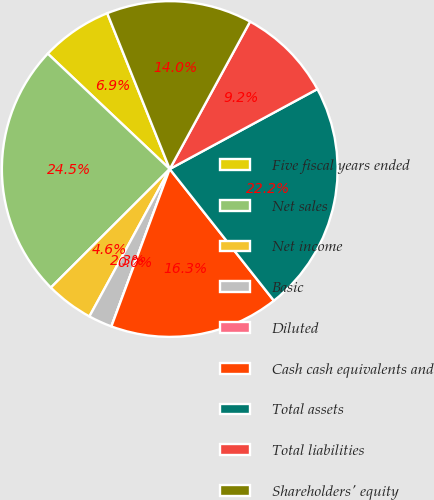<chart> <loc_0><loc_0><loc_500><loc_500><pie_chart><fcel>Five fiscal years ended<fcel>Net sales<fcel>Net income<fcel>Basic<fcel>Diluted<fcel>Cash cash equivalents and<fcel>Total assets<fcel>Total liabilities<fcel>Shareholders' equity<nl><fcel>6.87%<fcel>24.53%<fcel>4.58%<fcel>2.29%<fcel>0.0%<fcel>16.3%<fcel>22.24%<fcel>9.16%<fcel>14.01%<nl></chart> 